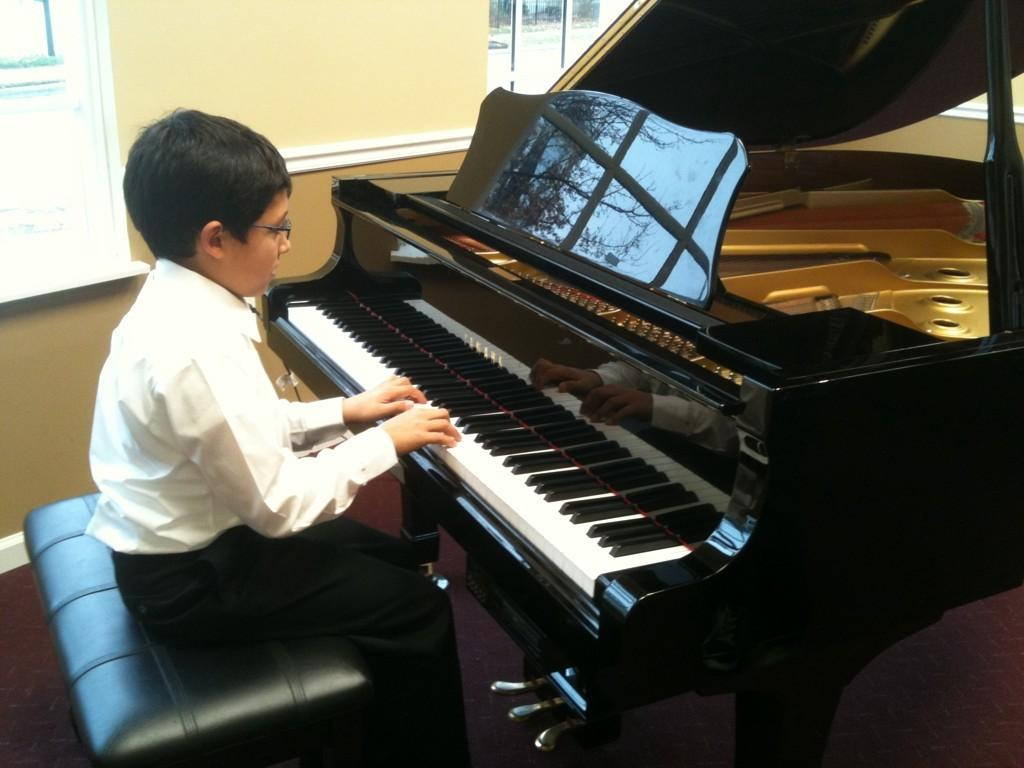What is the main subject of the picture? The main subject of the picture is a child. What is the child doing in the picture? The child is playing the piano. Where is the piano located in relation to the child? The piano is in front of the child. What is the child sitting on? The child is sitting on a table. What can be seen on the wall near the child? There is a wall with a window near the child. What type of feeling does the child express while reading a fictional story near the dock in the image? There is no dock or fictional story present in the image; the child is playing the piano while sitting on a table. 